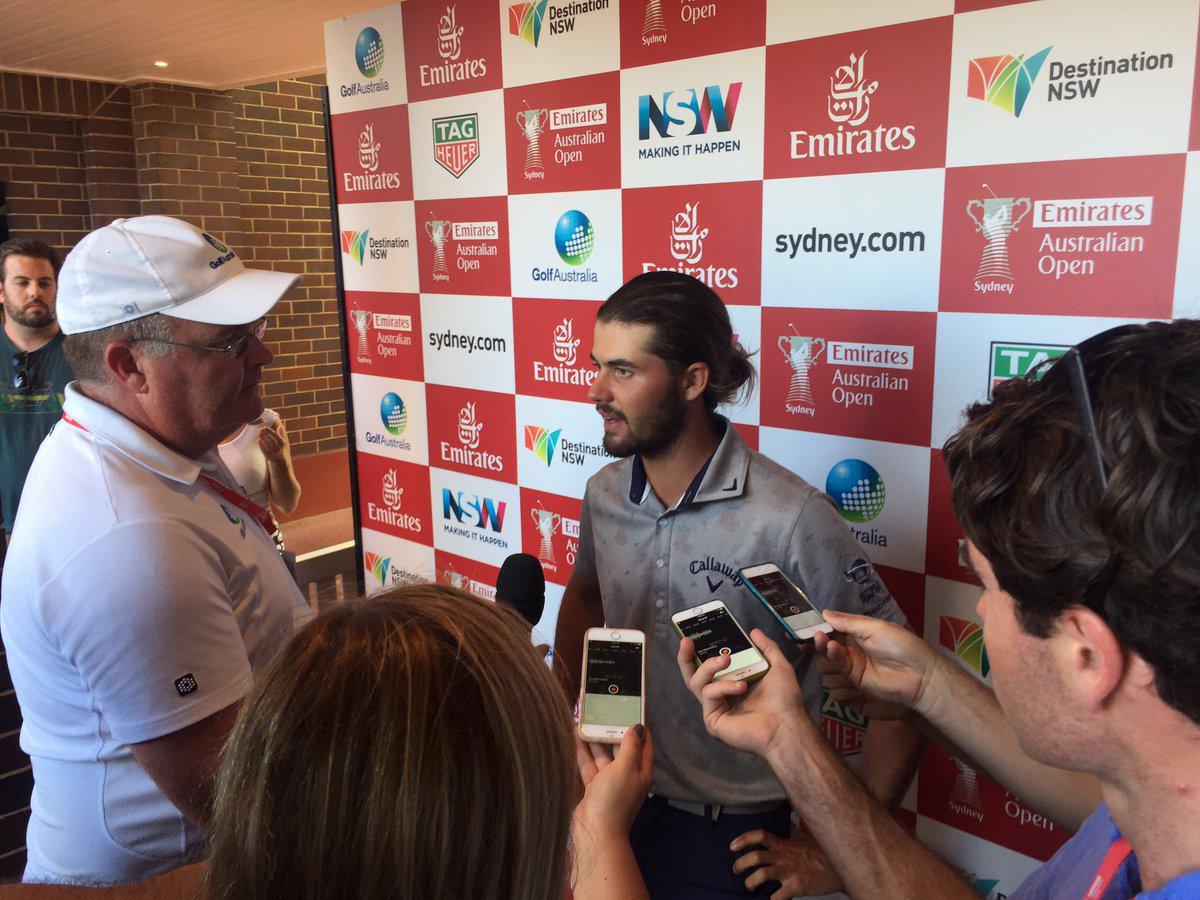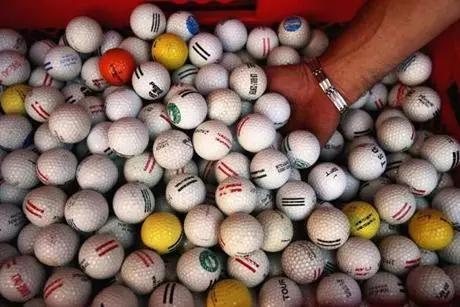The first image is the image on the left, the second image is the image on the right. Analyze the images presented: Is the assertion "There are so many golf balls; much more than twenty." valid? Answer yes or no. Yes. The first image is the image on the left, the second image is the image on the right. Examine the images to the left and right. Is the description "A person is sitting by golf balls in one of the images." accurate? Answer yes or no. No. 